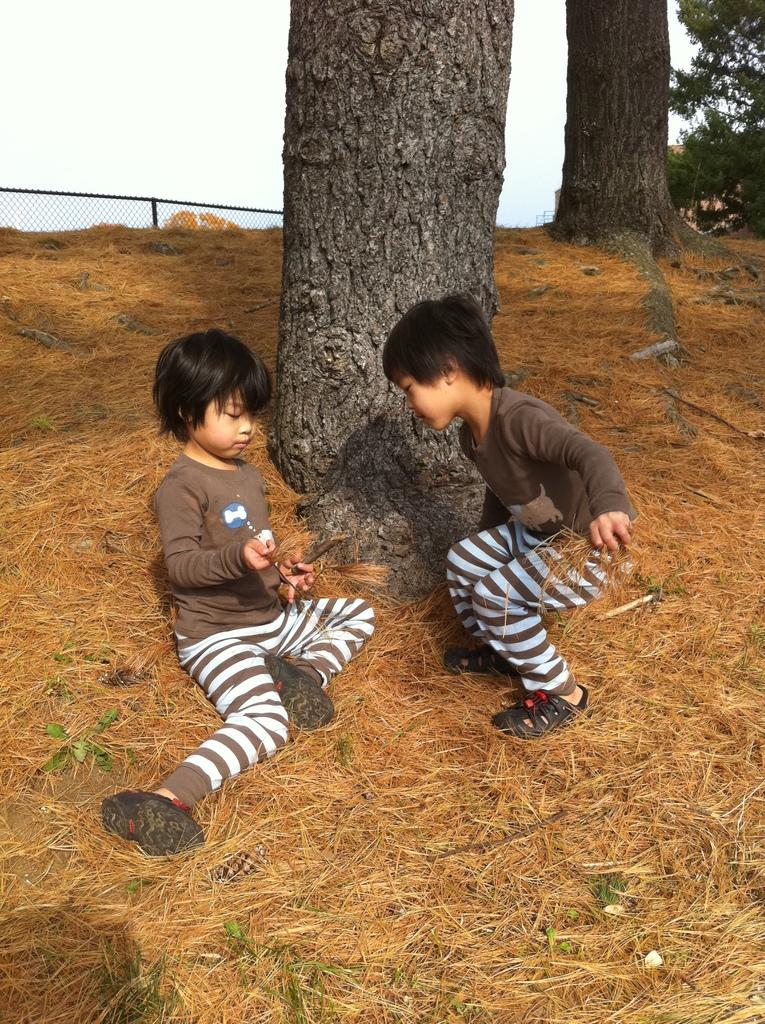How many children are in the image? There are two small boys in the image. What are the boys wearing? The boys are wearing brown t-shirts. Where are the boys sitting? The boys are sitting in dry grass. What can be seen in the background of the image? There is a tree trunk visible in the background of the image. What does the taste of the tree trunk in the background of the image suggest? There is no taste associated with the tree trunk in the image, as it is a visual representation and not a physical object that can be tasted. 